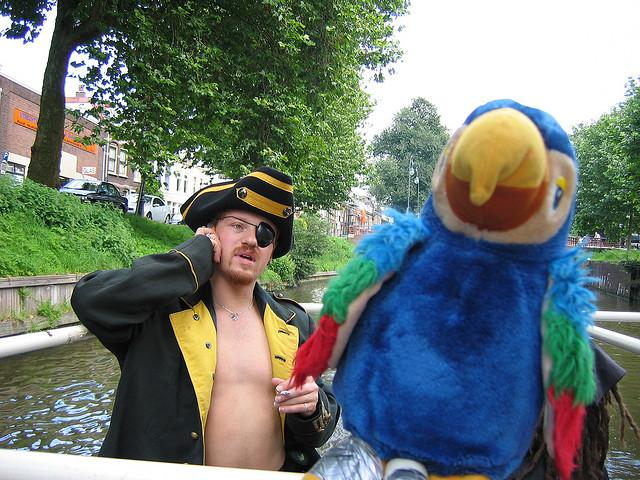What is the shirtless man dressed as?

Choices:
A) pirate
B) wrestler
C) cop
D) prisoner pirate 